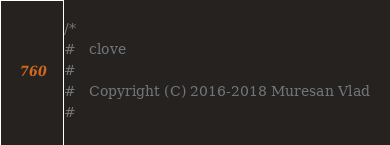Convert code to text. <code><loc_0><loc_0><loc_500><loc_500><_C_>/*
#   clove
#
#   Copyright (C) 2016-2018 Muresan Vlad
#</code> 